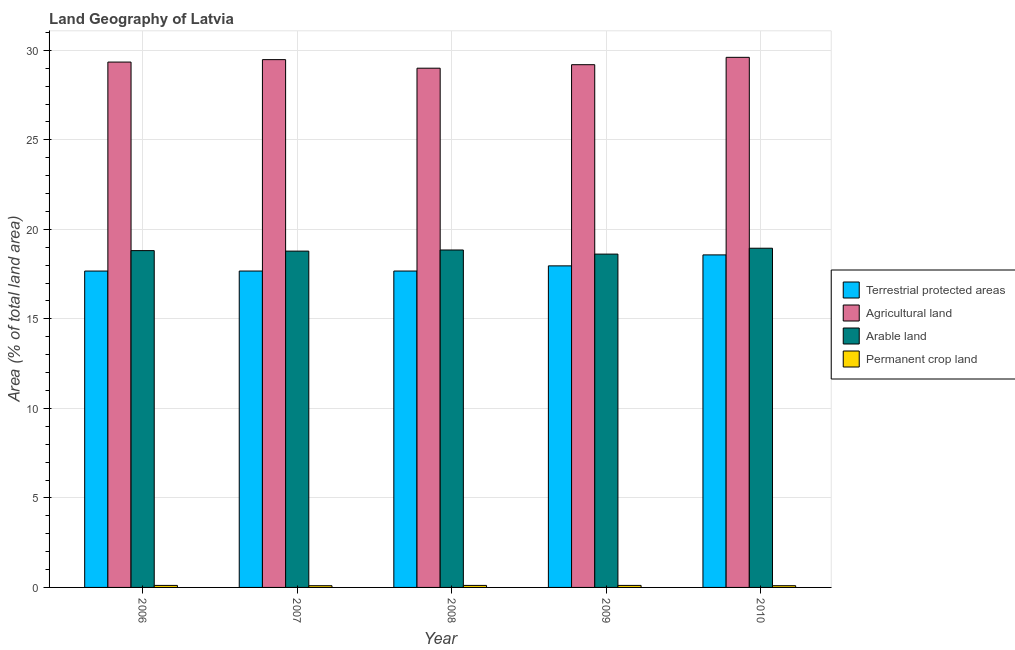Are the number of bars per tick equal to the number of legend labels?
Ensure brevity in your answer.  Yes. Are the number of bars on each tick of the X-axis equal?
Provide a short and direct response. Yes. How many bars are there on the 3rd tick from the left?
Keep it short and to the point. 4. How many bars are there on the 5th tick from the right?
Your answer should be compact. 4. In how many cases, is the number of bars for a given year not equal to the number of legend labels?
Offer a very short reply. 0. What is the percentage of land under terrestrial protection in 2006?
Make the answer very short. 17.67. Across all years, what is the maximum percentage of land under terrestrial protection?
Keep it short and to the point. 18.57. Across all years, what is the minimum percentage of area under arable land?
Ensure brevity in your answer.  18.62. In which year was the percentage of area under agricultural land maximum?
Provide a short and direct response. 2010. In which year was the percentage of land under terrestrial protection minimum?
Provide a succinct answer. 2006. What is the total percentage of area under arable land in the graph?
Keep it short and to the point. 94. What is the difference between the percentage of area under arable land in 2008 and that in 2010?
Your answer should be very brief. -0.1. What is the difference between the percentage of area under arable land in 2008 and the percentage of area under permanent crop land in 2009?
Offer a very short reply. 0.23. What is the average percentage of area under permanent crop land per year?
Keep it short and to the point. 0.11. In the year 2008, what is the difference between the percentage of area under permanent crop land and percentage of area under agricultural land?
Give a very brief answer. 0. What is the ratio of the percentage of area under agricultural land in 2007 to that in 2010?
Your answer should be compact. 1. Is the percentage of land under terrestrial protection in 2006 less than that in 2009?
Ensure brevity in your answer.  Yes. What is the difference between the highest and the second highest percentage of area under arable land?
Offer a terse response. 0.1. What is the difference between the highest and the lowest percentage of area under arable land?
Your answer should be very brief. 0.33. In how many years, is the percentage of area under agricultural land greater than the average percentage of area under agricultural land taken over all years?
Your answer should be compact. 3. Is the sum of the percentage of area under permanent crop land in 2006 and 2009 greater than the maximum percentage of area under agricultural land across all years?
Your response must be concise. Yes. What does the 2nd bar from the left in 2006 represents?
Provide a succinct answer. Agricultural land. What does the 4th bar from the right in 2007 represents?
Your answer should be compact. Terrestrial protected areas. Is it the case that in every year, the sum of the percentage of land under terrestrial protection and percentage of area under agricultural land is greater than the percentage of area under arable land?
Make the answer very short. Yes. Are all the bars in the graph horizontal?
Give a very brief answer. No. How many years are there in the graph?
Offer a very short reply. 5. Are the values on the major ticks of Y-axis written in scientific E-notation?
Your answer should be very brief. No. Does the graph contain grids?
Provide a short and direct response. Yes. How many legend labels are there?
Offer a very short reply. 4. How are the legend labels stacked?
Offer a very short reply. Vertical. What is the title of the graph?
Offer a very short reply. Land Geography of Latvia. Does "Pre-primary schools" appear as one of the legend labels in the graph?
Your answer should be compact. No. What is the label or title of the Y-axis?
Provide a succinct answer. Area (% of total land area). What is the Area (% of total land area) in Terrestrial protected areas in 2006?
Your answer should be very brief. 17.67. What is the Area (% of total land area) in Agricultural land in 2006?
Your response must be concise. 29.34. What is the Area (% of total land area) in Arable land in 2006?
Your answer should be compact. 18.81. What is the Area (% of total land area) in Permanent crop land in 2006?
Ensure brevity in your answer.  0.11. What is the Area (% of total land area) in Terrestrial protected areas in 2007?
Keep it short and to the point. 17.67. What is the Area (% of total land area) of Agricultural land in 2007?
Your answer should be very brief. 29.48. What is the Area (% of total land area) in Arable land in 2007?
Offer a terse response. 18.78. What is the Area (% of total land area) of Permanent crop land in 2007?
Keep it short and to the point. 0.1. What is the Area (% of total land area) of Terrestrial protected areas in 2008?
Make the answer very short. 17.67. What is the Area (% of total land area) in Agricultural land in 2008?
Offer a very short reply. 29. What is the Area (% of total land area) in Arable land in 2008?
Keep it short and to the point. 18.85. What is the Area (% of total land area) in Permanent crop land in 2008?
Your answer should be very brief. 0.11. What is the Area (% of total land area) in Terrestrial protected areas in 2009?
Offer a terse response. 17.96. What is the Area (% of total land area) of Agricultural land in 2009?
Keep it short and to the point. 29.2. What is the Area (% of total land area) in Arable land in 2009?
Offer a very short reply. 18.62. What is the Area (% of total land area) of Permanent crop land in 2009?
Offer a terse response. 0.11. What is the Area (% of total land area) of Terrestrial protected areas in 2010?
Offer a very short reply. 18.57. What is the Area (% of total land area) of Agricultural land in 2010?
Provide a succinct answer. 29.61. What is the Area (% of total land area) in Arable land in 2010?
Provide a succinct answer. 18.94. What is the Area (% of total land area) in Permanent crop land in 2010?
Keep it short and to the point. 0.1. Across all years, what is the maximum Area (% of total land area) in Terrestrial protected areas?
Ensure brevity in your answer.  18.57. Across all years, what is the maximum Area (% of total land area) of Agricultural land?
Provide a short and direct response. 29.61. Across all years, what is the maximum Area (% of total land area) of Arable land?
Your response must be concise. 18.94. Across all years, what is the maximum Area (% of total land area) in Permanent crop land?
Your response must be concise. 0.11. Across all years, what is the minimum Area (% of total land area) in Terrestrial protected areas?
Give a very brief answer. 17.67. Across all years, what is the minimum Area (% of total land area) in Agricultural land?
Offer a very short reply. 29. Across all years, what is the minimum Area (% of total land area) of Arable land?
Your response must be concise. 18.62. Across all years, what is the minimum Area (% of total land area) of Permanent crop land?
Offer a terse response. 0.1. What is the total Area (% of total land area) of Terrestrial protected areas in the graph?
Make the answer very short. 89.55. What is the total Area (% of total land area) in Agricultural land in the graph?
Give a very brief answer. 146.63. What is the total Area (% of total land area) in Arable land in the graph?
Provide a succinct answer. 94. What is the total Area (% of total land area) in Permanent crop land in the graph?
Your answer should be compact. 0.53. What is the difference between the Area (% of total land area) in Terrestrial protected areas in 2006 and that in 2007?
Your answer should be very brief. -0. What is the difference between the Area (% of total land area) of Agricultural land in 2006 and that in 2007?
Your answer should be very brief. -0.14. What is the difference between the Area (% of total land area) of Arable land in 2006 and that in 2007?
Offer a very short reply. 0.03. What is the difference between the Area (% of total land area) of Permanent crop land in 2006 and that in 2007?
Keep it short and to the point. 0.02. What is the difference between the Area (% of total land area) in Terrestrial protected areas in 2006 and that in 2008?
Offer a very short reply. -0. What is the difference between the Area (% of total land area) of Agricultural land in 2006 and that in 2008?
Your answer should be compact. 0.34. What is the difference between the Area (% of total land area) of Arable land in 2006 and that in 2008?
Ensure brevity in your answer.  -0.03. What is the difference between the Area (% of total land area) of Permanent crop land in 2006 and that in 2008?
Ensure brevity in your answer.  0. What is the difference between the Area (% of total land area) of Terrestrial protected areas in 2006 and that in 2009?
Your response must be concise. -0.29. What is the difference between the Area (% of total land area) of Agricultural land in 2006 and that in 2009?
Offer a very short reply. 0.15. What is the difference between the Area (% of total land area) of Arable land in 2006 and that in 2009?
Your response must be concise. 0.19. What is the difference between the Area (% of total land area) in Terrestrial protected areas in 2006 and that in 2010?
Provide a succinct answer. -0.9. What is the difference between the Area (% of total land area) in Agricultural land in 2006 and that in 2010?
Give a very brief answer. -0.26. What is the difference between the Area (% of total land area) in Arable land in 2006 and that in 2010?
Your answer should be compact. -0.13. What is the difference between the Area (% of total land area) of Permanent crop land in 2006 and that in 2010?
Give a very brief answer. 0.02. What is the difference between the Area (% of total land area) of Terrestrial protected areas in 2007 and that in 2008?
Your answer should be compact. 0. What is the difference between the Area (% of total land area) in Agricultural land in 2007 and that in 2008?
Your response must be concise. 0.48. What is the difference between the Area (% of total land area) in Arable land in 2007 and that in 2008?
Your answer should be very brief. -0.06. What is the difference between the Area (% of total land area) of Permanent crop land in 2007 and that in 2008?
Offer a very short reply. -0.02. What is the difference between the Area (% of total land area) of Terrestrial protected areas in 2007 and that in 2009?
Provide a succinct answer. -0.29. What is the difference between the Area (% of total land area) in Agricultural land in 2007 and that in 2009?
Provide a short and direct response. 0.28. What is the difference between the Area (% of total land area) of Arable land in 2007 and that in 2009?
Offer a terse response. 0.17. What is the difference between the Area (% of total land area) in Permanent crop land in 2007 and that in 2009?
Offer a terse response. -0.02. What is the difference between the Area (% of total land area) in Terrestrial protected areas in 2007 and that in 2010?
Make the answer very short. -0.9. What is the difference between the Area (% of total land area) of Agricultural land in 2007 and that in 2010?
Your response must be concise. -0.13. What is the difference between the Area (% of total land area) in Arable land in 2007 and that in 2010?
Your answer should be very brief. -0.16. What is the difference between the Area (% of total land area) in Permanent crop land in 2007 and that in 2010?
Your answer should be compact. 0. What is the difference between the Area (% of total land area) in Terrestrial protected areas in 2008 and that in 2009?
Give a very brief answer. -0.29. What is the difference between the Area (% of total land area) in Agricultural land in 2008 and that in 2009?
Ensure brevity in your answer.  -0.2. What is the difference between the Area (% of total land area) in Arable land in 2008 and that in 2009?
Your response must be concise. 0.23. What is the difference between the Area (% of total land area) in Permanent crop land in 2008 and that in 2009?
Provide a succinct answer. -0. What is the difference between the Area (% of total land area) of Terrestrial protected areas in 2008 and that in 2010?
Provide a short and direct response. -0.9. What is the difference between the Area (% of total land area) in Agricultural land in 2008 and that in 2010?
Provide a succinct answer. -0.61. What is the difference between the Area (% of total land area) in Arable land in 2008 and that in 2010?
Give a very brief answer. -0.1. What is the difference between the Area (% of total land area) in Permanent crop land in 2008 and that in 2010?
Provide a succinct answer. 0.02. What is the difference between the Area (% of total land area) of Terrestrial protected areas in 2009 and that in 2010?
Offer a very short reply. -0.61. What is the difference between the Area (% of total land area) in Agricultural land in 2009 and that in 2010?
Provide a short and direct response. -0.41. What is the difference between the Area (% of total land area) in Arable land in 2009 and that in 2010?
Keep it short and to the point. -0.33. What is the difference between the Area (% of total land area) in Permanent crop land in 2009 and that in 2010?
Offer a terse response. 0.02. What is the difference between the Area (% of total land area) of Terrestrial protected areas in 2006 and the Area (% of total land area) of Agricultural land in 2007?
Make the answer very short. -11.81. What is the difference between the Area (% of total land area) of Terrestrial protected areas in 2006 and the Area (% of total land area) of Arable land in 2007?
Your answer should be very brief. -1.11. What is the difference between the Area (% of total land area) of Terrestrial protected areas in 2006 and the Area (% of total land area) of Permanent crop land in 2007?
Offer a very short reply. 17.57. What is the difference between the Area (% of total land area) in Agricultural land in 2006 and the Area (% of total land area) in Arable land in 2007?
Your answer should be compact. 10.56. What is the difference between the Area (% of total land area) of Agricultural land in 2006 and the Area (% of total land area) of Permanent crop land in 2007?
Ensure brevity in your answer.  29.25. What is the difference between the Area (% of total land area) of Arable land in 2006 and the Area (% of total land area) of Permanent crop land in 2007?
Offer a terse response. 18.71. What is the difference between the Area (% of total land area) of Terrestrial protected areas in 2006 and the Area (% of total land area) of Agricultural land in 2008?
Offer a very short reply. -11.33. What is the difference between the Area (% of total land area) in Terrestrial protected areas in 2006 and the Area (% of total land area) in Arable land in 2008?
Make the answer very short. -1.18. What is the difference between the Area (% of total land area) of Terrestrial protected areas in 2006 and the Area (% of total land area) of Permanent crop land in 2008?
Provide a short and direct response. 17.56. What is the difference between the Area (% of total land area) of Agricultural land in 2006 and the Area (% of total land area) of Arable land in 2008?
Offer a terse response. 10.5. What is the difference between the Area (% of total land area) of Agricultural land in 2006 and the Area (% of total land area) of Permanent crop land in 2008?
Keep it short and to the point. 29.23. What is the difference between the Area (% of total land area) of Arable land in 2006 and the Area (% of total land area) of Permanent crop land in 2008?
Ensure brevity in your answer.  18.7. What is the difference between the Area (% of total land area) in Terrestrial protected areas in 2006 and the Area (% of total land area) in Agricultural land in 2009?
Your answer should be very brief. -11.53. What is the difference between the Area (% of total land area) in Terrestrial protected areas in 2006 and the Area (% of total land area) in Arable land in 2009?
Offer a terse response. -0.95. What is the difference between the Area (% of total land area) in Terrestrial protected areas in 2006 and the Area (% of total land area) in Permanent crop land in 2009?
Offer a terse response. 17.56. What is the difference between the Area (% of total land area) in Agricultural land in 2006 and the Area (% of total land area) in Arable land in 2009?
Your answer should be very brief. 10.73. What is the difference between the Area (% of total land area) of Agricultural land in 2006 and the Area (% of total land area) of Permanent crop land in 2009?
Offer a terse response. 29.23. What is the difference between the Area (% of total land area) in Arable land in 2006 and the Area (% of total land area) in Permanent crop land in 2009?
Provide a succinct answer. 18.7. What is the difference between the Area (% of total land area) of Terrestrial protected areas in 2006 and the Area (% of total land area) of Agricultural land in 2010?
Keep it short and to the point. -11.94. What is the difference between the Area (% of total land area) of Terrestrial protected areas in 2006 and the Area (% of total land area) of Arable land in 2010?
Your answer should be very brief. -1.27. What is the difference between the Area (% of total land area) of Terrestrial protected areas in 2006 and the Area (% of total land area) of Permanent crop land in 2010?
Ensure brevity in your answer.  17.57. What is the difference between the Area (% of total land area) in Agricultural land in 2006 and the Area (% of total land area) in Arable land in 2010?
Your response must be concise. 10.4. What is the difference between the Area (% of total land area) in Agricultural land in 2006 and the Area (% of total land area) in Permanent crop land in 2010?
Your answer should be very brief. 29.25. What is the difference between the Area (% of total land area) of Arable land in 2006 and the Area (% of total land area) of Permanent crop land in 2010?
Offer a terse response. 18.71. What is the difference between the Area (% of total land area) of Terrestrial protected areas in 2007 and the Area (% of total land area) of Agricultural land in 2008?
Ensure brevity in your answer.  -11.33. What is the difference between the Area (% of total land area) of Terrestrial protected areas in 2007 and the Area (% of total land area) of Arable land in 2008?
Your answer should be compact. -1.18. What is the difference between the Area (% of total land area) of Terrestrial protected areas in 2007 and the Area (% of total land area) of Permanent crop land in 2008?
Give a very brief answer. 17.56. What is the difference between the Area (% of total land area) of Agricultural land in 2007 and the Area (% of total land area) of Arable land in 2008?
Provide a short and direct response. 10.63. What is the difference between the Area (% of total land area) of Agricultural land in 2007 and the Area (% of total land area) of Permanent crop land in 2008?
Provide a succinct answer. 29.37. What is the difference between the Area (% of total land area) in Arable land in 2007 and the Area (% of total land area) in Permanent crop land in 2008?
Your response must be concise. 18.67. What is the difference between the Area (% of total land area) of Terrestrial protected areas in 2007 and the Area (% of total land area) of Agricultural land in 2009?
Give a very brief answer. -11.53. What is the difference between the Area (% of total land area) of Terrestrial protected areas in 2007 and the Area (% of total land area) of Arable land in 2009?
Your answer should be compact. -0.95. What is the difference between the Area (% of total land area) of Terrestrial protected areas in 2007 and the Area (% of total land area) of Permanent crop land in 2009?
Ensure brevity in your answer.  17.56. What is the difference between the Area (% of total land area) in Agricultural land in 2007 and the Area (% of total land area) in Arable land in 2009?
Your answer should be compact. 10.86. What is the difference between the Area (% of total land area) in Agricultural land in 2007 and the Area (% of total land area) in Permanent crop land in 2009?
Offer a terse response. 29.37. What is the difference between the Area (% of total land area) in Arable land in 2007 and the Area (% of total land area) in Permanent crop land in 2009?
Your response must be concise. 18.67. What is the difference between the Area (% of total land area) in Terrestrial protected areas in 2007 and the Area (% of total land area) in Agricultural land in 2010?
Keep it short and to the point. -11.94. What is the difference between the Area (% of total land area) of Terrestrial protected areas in 2007 and the Area (% of total land area) of Arable land in 2010?
Provide a short and direct response. -1.27. What is the difference between the Area (% of total land area) in Terrestrial protected areas in 2007 and the Area (% of total land area) in Permanent crop land in 2010?
Keep it short and to the point. 17.57. What is the difference between the Area (% of total land area) of Agricultural land in 2007 and the Area (% of total land area) of Arable land in 2010?
Give a very brief answer. 10.53. What is the difference between the Area (% of total land area) of Agricultural land in 2007 and the Area (% of total land area) of Permanent crop land in 2010?
Offer a terse response. 29.38. What is the difference between the Area (% of total land area) in Arable land in 2007 and the Area (% of total land area) in Permanent crop land in 2010?
Give a very brief answer. 18.69. What is the difference between the Area (% of total land area) of Terrestrial protected areas in 2008 and the Area (% of total land area) of Agricultural land in 2009?
Give a very brief answer. -11.53. What is the difference between the Area (% of total land area) in Terrestrial protected areas in 2008 and the Area (% of total land area) in Arable land in 2009?
Your answer should be compact. -0.95. What is the difference between the Area (% of total land area) of Terrestrial protected areas in 2008 and the Area (% of total land area) of Permanent crop land in 2009?
Provide a short and direct response. 17.56. What is the difference between the Area (% of total land area) of Agricultural land in 2008 and the Area (% of total land area) of Arable land in 2009?
Your answer should be compact. 10.38. What is the difference between the Area (% of total land area) in Agricultural land in 2008 and the Area (% of total land area) in Permanent crop land in 2009?
Your response must be concise. 28.89. What is the difference between the Area (% of total land area) in Arable land in 2008 and the Area (% of total land area) in Permanent crop land in 2009?
Offer a terse response. 18.73. What is the difference between the Area (% of total land area) of Terrestrial protected areas in 2008 and the Area (% of total land area) of Agricultural land in 2010?
Keep it short and to the point. -11.94. What is the difference between the Area (% of total land area) in Terrestrial protected areas in 2008 and the Area (% of total land area) in Arable land in 2010?
Provide a short and direct response. -1.27. What is the difference between the Area (% of total land area) in Terrestrial protected areas in 2008 and the Area (% of total land area) in Permanent crop land in 2010?
Give a very brief answer. 17.57. What is the difference between the Area (% of total land area) in Agricultural land in 2008 and the Area (% of total land area) in Arable land in 2010?
Your answer should be compact. 10.06. What is the difference between the Area (% of total land area) in Agricultural land in 2008 and the Area (% of total land area) in Permanent crop land in 2010?
Give a very brief answer. 28.9. What is the difference between the Area (% of total land area) of Arable land in 2008 and the Area (% of total land area) of Permanent crop land in 2010?
Provide a short and direct response. 18.75. What is the difference between the Area (% of total land area) in Terrestrial protected areas in 2009 and the Area (% of total land area) in Agricultural land in 2010?
Your answer should be very brief. -11.65. What is the difference between the Area (% of total land area) of Terrestrial protected areas in 2009 and the Area (% of total land area) of Arable land in 2010?
Provide a short and direct response. -0.98. What is the difference between the Area (% of total land area) in Terrestrial protected areas in 2009 and the Area (% of total land area) in Permanent crop land in 2010?
Make the answer very short. 17.86. What is the difference between the Area (% of total land area) in Agricultural land in 2009 and the Area (% of total land area) in Arable land in 2010?
Your answer should be very brief. 10.25. What is the difference between the Area (% of total land area) of Agricultural land in 2009 and the Area (% of total land area) of Permanent crop land in 2010?
Provide a succinct answer. 29.1. What is the difference between the Area (% of total land area) in Arable land in 2009 and the Area (% of total land area) in Permanent crop land in 2010?
Your answer should be very brief. 18.52. What is the average Area (% of total land area) in Terrestrial protected areas per year?
Offer a terse response. 17.91. What is the average Area (% of total land area) of Agricultural land per year?
Provide a short and direct response. 29.33. What is the average Area (% of total land area) of Arable land per year?
Your answer should be compact. 18.8. What is the average Area (% of total land area) in Permanent crop land per year?
Provide a succinct answer. 0.11. In the year 2006, what is the difference between the Area (% of total land area) of Terrestrial protected areas and Area (% of total land area) of Agricultural land?
Give a very brief answer. -11.67. In the year 2006, what is the difference between the Area (% of total land area) of Terrestrial protected areas and Area (% of total land area) of Arable land?
Offer a very short reply. -1.14. In the year 2006, what is the difference between the Area (% of total land area) of Terrestrial protected areas and Area (% of total land area) of Permanent crop land?
Offer a terse response. 17.56. In the year 2006, what is the difference between the Area (% of total land area) in Agricultural land and Area (% of total land area) in Arable land?
Offer a very short reply. 10.53. In the year 2006, what is the difference between the Area (% of total land area) of Agricultural land and Area (% of total land area) of Permanent crop land?
Offer a terse response. 29.23. In the year 2006, what is the difference between the Area (% of total land area) in Arable land and Area (% of total land area) in Permanent crop land?
Offer a very short reply. 18.7. In the year 2007, what is the difference between the Area (% of total land area) in Terrestrial protected areas and Area (% of total land area) in Agricultural land?
Offer a very short reply. -11.81. In the year 2007, what is the difference between the Area (% of total land area) of Terrestrial protected areas and Area (% of total land area) of Arable land?
Keep it short and to the point. -1.11. In the year 2007, what is the difference between the Area (% of total land area) of Terrestrial protected areas and Area (% of total land area) of Permanent crop land?
Offer a terse response. 17.57. In the year 2007, what is the difference between the Area (% of total land area) of Agricultural land and Area (% of total land area) of Arable land?
Offer a very short reply. 10.69. In the year 2007, what is the difference between the Area (% of total land area) in Agricultural land and Area (% of total land area) in Permanent crop land?
Your answer should be very brief. 29.38. In the year 2007, what is the difference between the Area (% of total land area) in Arable land and Area (% of total land area) in Permanent crop land?
Provide a succinct answer. 18.69. In the year 2008, what is the difference between the Area (% of total land area) of Terrestrial protected areas and Area (% of total land area) of Agricultural land?
Offer a terse response. -11.33. In the year 2008, what is the difference between the Area (% of total land area) in Terrestrial protected areas and Area (% of total land area) in Arable land?
Your answer should be very brief. -1.18. In the year 2008, what is the difference between the Area (% of total land area) in Terrestrial protected areas and Area (% of total land area) in Permanent crop land?
Offer a terse response. 17.56. In the year 2008, what is the difference between the Area (% of total land area) in Agricultural land and Area (% of total land area) in Arable land?
Your answer should be compact. 10.15. In the year 2008, what is the difference between the Area (% of total land area) in Agricultural land and Area (% of total land area) in Permanent crop land?
Give a very brief answer. 28.89. In the year 2008, what is the difference between the Area (% of total land area) in Arable land and Area (% of total land area) in Permanent crop land?
Give a very brief answer. 18.73. In the year 2009, what is the difference between the Area (% of total land area) in Terrestrial protected areas and Area (% of total land area) in Agricultural land?
Your answer should be compact. -11.24. In the year 2009, what is the difference between the Area (% of total land area) of Terrestrial protected areas and Area (% of total land area) of Arable land?
Keep it short and to the point. -0.66. In the year 2009, what is the difference between the Area (% of total land area) of Terrestrial protected areas and Area (% of total land area) of Permanent crop land?
Make the answer very short. 17.85. In the year 2009, what is the difference between the Area (% of total land area) in Agricultural land and Area (% of total land area) in Arable land?
Give a very brief answer. 10.58. In the year 2009, what is the difference between the Area (% of total land area) of Agricultural land and Area (% of total land area) of Permanent crop land?
Your answer should be very brief. 29.08. In the year 2009, what is the difference between the Area (% of total land area) in Arable land and Area (% of total land area) in Permanent crop land?
Your answer should be compact. 18.5. In the year 2010, what is the difference between the Area (% of total land area) of Terrestrial protected areas and Area (% of total land area) of Agricultural land?
Provide a short and direct response. -11.04. In the year 2010, what is the difference between the Area (% of total land area) of Terrestrial protected areas and Area (% of total land area) of Arable land?
Provide a short and direct response. -0.37. In the year 2010, what is the difference between the Area (% of total land area) in Terrestrial protected areas and Area (% of total land area) in Permanent crop land?
Your answer should be compact. 18.48. In the year 2010, what is the difference between the Area (% of total land area) in Agricultural land and Area (% of total land area) in Arable land?
Offer a terse response. 10.66. In the year 2010, what is the difference between the Area (% of total land area) in Agricultural land and Area (% of total land area) in Permanent crop land?
Ensure brevity in your answer.  29.51. In the year 2010, what is the difference between the Area (% of total land area) of Arable land and Area (% of total land area) of Permanent crop land?
Your answer should be compact. 18.85. What is the ratio of the Area (% of total land area) of Terrestrial protected areas in 2006 to that in 2007?
Keep it short and to the point. 1. What is the ratio of the Area (% of total land area) of Agricultural land in 2006 to that in 2007?
Your answer should be compact. 1. What is the ratio of the Area (% of total land area) of Permanent crop land in 2006 to that in 2007?
Offer a very short reply. 1.17. What is the ratio of the Area (% of total land area) in Agricultural land in 2006 to that in 2008?
Your response must be concise. 1.01. What is the ratio of the Area (% of total land area) in Terrestrial protected areas in 2006 to that in 2009?
Make the answer very short. 0.98. What is the ratio of the Area (% of total land area) of Agricultural land in 2006 to that in 2009?
Ensure brevity in your answer.  1. What is the ratio of the Area (% of total land area) of Arable land in 2006 to that in 2009?
Offer a very short reply. 1.01. What is the ratio of the Area (% of total land area) of Terrestrial protected areas in 2006 to that in 2010?
Provide a short and direct response. 0.95. What is the ratio of the Area (% of total land area) of Permanent crop land in 2006 to that in 2010?
Keep it short and to the point. 1.17. What is the ratio of the Area (% of total land area) of Agricultural land in 2007 to that in 2008?
Provide a short and direct response. 1.02. What is the ratio of the Area (% of total land area) of Permanent crop land in 2007 to that in 2008?
Give a very brief answer. 0.86. What is the ratio of the Area (% of total land area) of Terrestrial protected areas in 2007 to that in 2009?
Your answer should be very brief. 0.98. What is the ratio of the Area (% of total land area) in Agricultural land in 2007 to that in 2009?
Your answer should be compact. 1.01. What is the ratio of the Area (% of total land area) of Arable land in 2007 to that in 2009?
Ensure brevity in your answer.  1.01. What is the ratio of the Area (% of total land area) of Permanent crop land in 2007 to that in 2009?
Make the answer very short. 0.86. What is the ratio of the Area (% of total land area) of Terrestrial protected areas in 2007 to that in 2010?
Keep it short and to the point. 0.95. What is the ratio of the Area (% of total land area) in Arable land in 2007 to that in 2010?
Provide a short and direct response. 0.99. What is the ratio of the Area (% of total land area) in Permanent crop land in 2007 to that in 2010?
Provide a short and direct response. 1. What is the ratio of the Area (% of total land area) in Terrestrial protected areas in 2008 to that in 2009?
Your answer should be compact. 0.98. What is the ratio of the Area (% of total land area) in Arable land in 2008 to that in 2009?
Provide a succinct answer. 1.01. What is the ratio of the Area (% of total land area) of Terrestrial protected areas in 2008 to that in 2010?
Your answer should be very brief. 0.95. What is the ratio of the Area (% of total land area) in Agricultural land in 2008 to that in 2010?
Your answer should be compact. 0.98. What is the ratio of the Area (% of total land area) of Arable land in 2008 to that in 2010?
Your answer should be compact. 0.99. What is the ratio of the Area (% of total land area) of Permanent crop land in 2008 to that in 2010?
Provide a succinct answer. 1.17. What is the ratio of the Area (% of total land area) of Agricultural land in 2009 to that in 2010?
Ensure brevity in your answer.  0.99. What is the ratio of the Area (% of total land area) in Arable land in 2009 to that in 2010?
Your response must be concise. 0.98. What is the ratio of the Area (% of total land area) in Permanent crop land in 2009 to that in 2010?
Ensure brevity in your answer.  1.17. What is the difference between the highest and the second highest Area (% of total land area) in Terrestrial protected areas?
Make the answer very short. 0.61. What is the difference between the highest and the second highest Area (% of total land area) in Agricultural land?
Your answer should be compact. 0.13. What is the difference between the highest and the second highest Area (% of total land area) in Arable land?
Make the answer very short. 0.1. What is the difference between the highest and the second highest Area (% of total land area) of Permanent crop land?
Provide a short and direct response. 0. What is the difference between the highest and the lowest Area (% of total land area) of Terrestrial protected areas?
Keep it short and to the point. 0.9. What is the difference between the highest and the lowest Area (% of total land area) of Agricultural land?
Make the answer very short. 0.61. What is the difference between the highest and the lowest Area (% of total land area) of Arable land?
Provide a short and direct response. 0.33. What is the difference between the highest and the lowest Area (% of total land area) of Permanent crop land?
Offer a terse response. 0.02. 